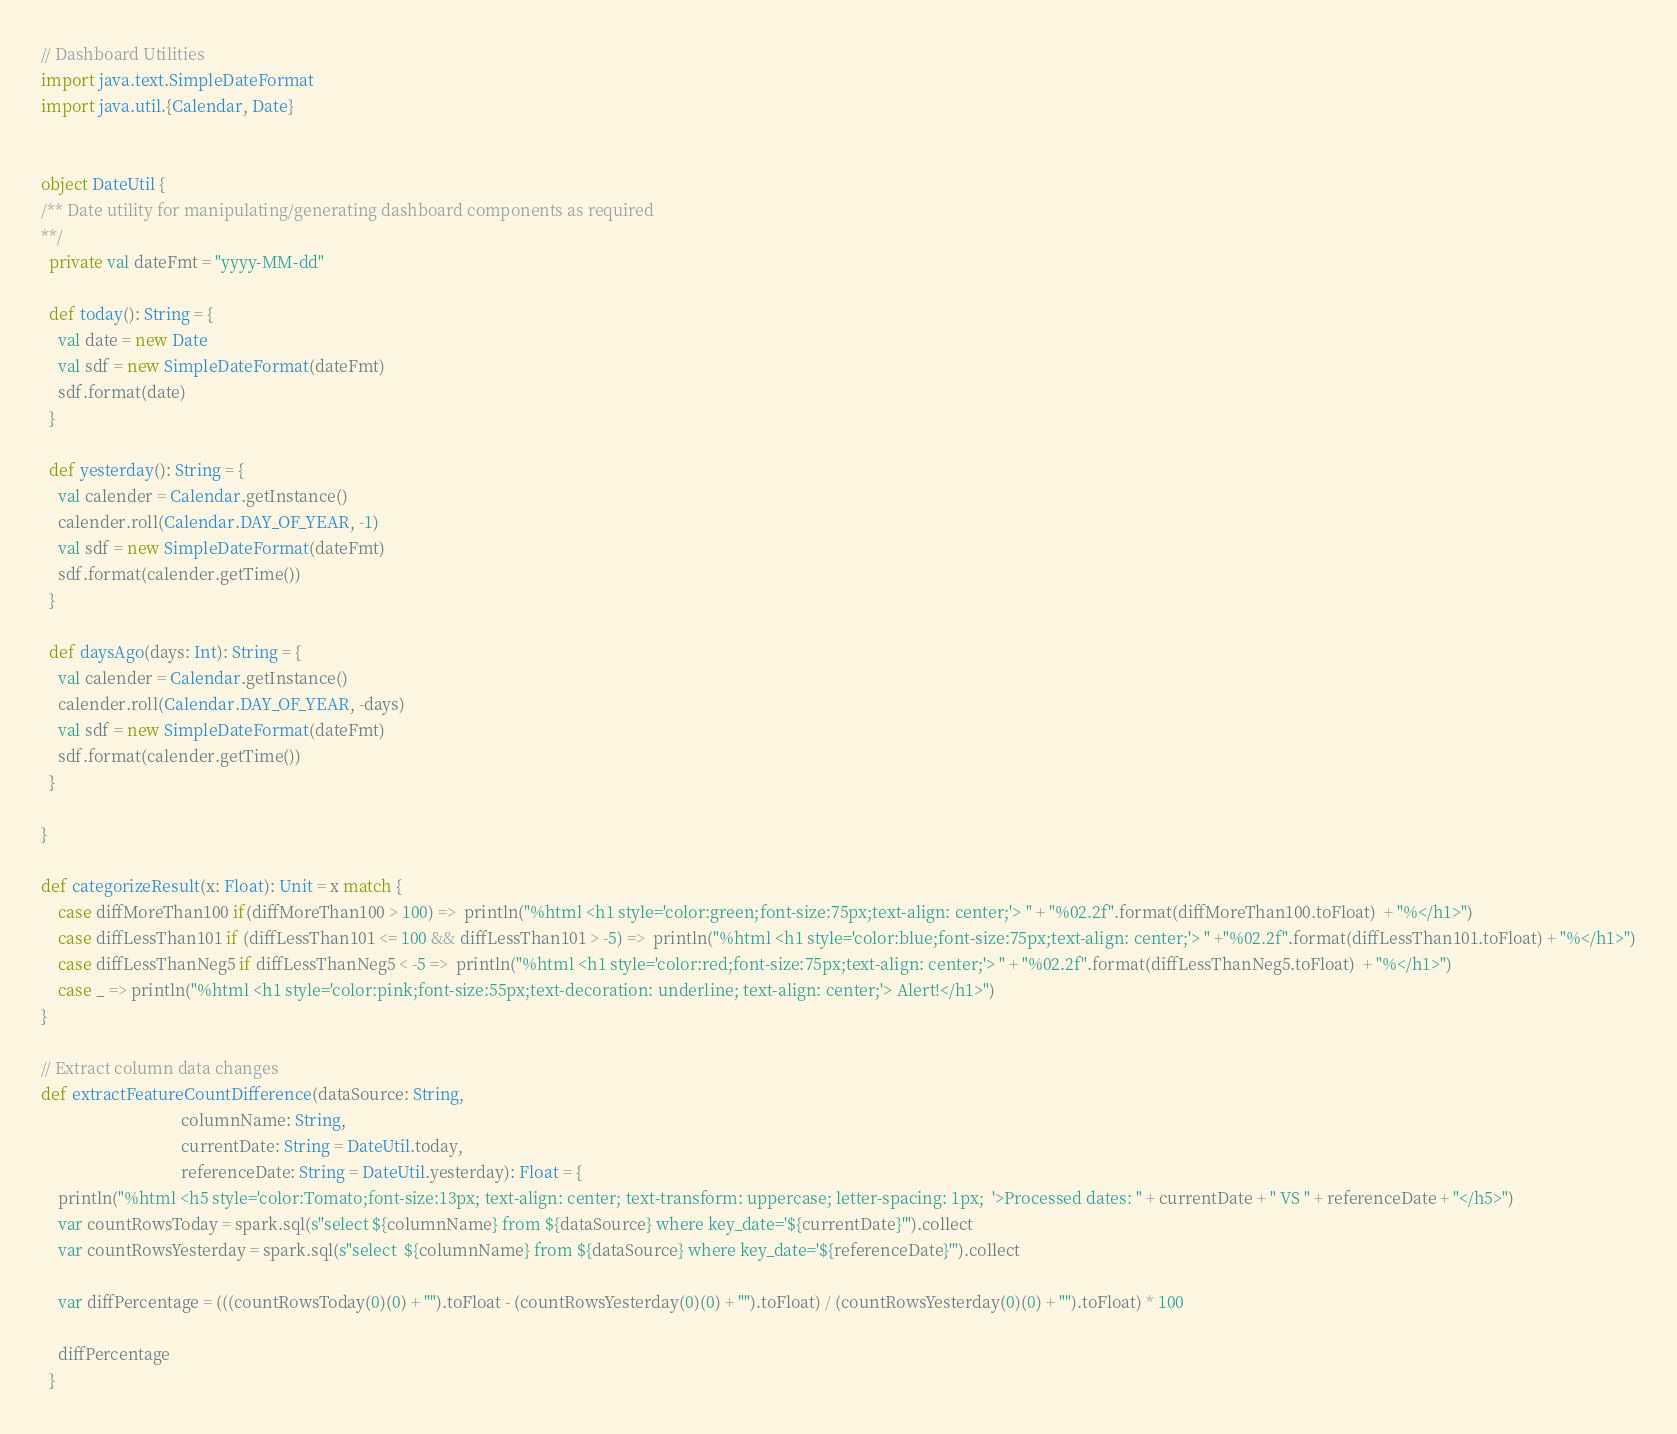Convert code to text. <code><loc_0><loc_0><loc_500><loc_500><_Scala_>// Dashboard Utilities
import java.text.SimpleDateFormat
import java.util.{Calendar, Date}


object DateUtil {
/** Date utility for manipulating/generating dashboard components as required
**/
  private val dateFmt = "yyyy-MM-dd"

  def today(): String = {
    val date = new Date
    val sdf = new SimpleDateFormat(dateFmt)
    sdf.format(date)
  }

  def yesterday(): String = {
    val calender = Calendar.getInstance()
    calender.roll(Calendar.DAY_OF_YEAR, -1)
    val sdf = new SimpleDateFormat(dateFmt)
    sdf.format(calender.getTime())
  }

  def daysAgo(days: Int): String = {
    val calender = Calendar.getInstance()
    calender.roll(Calendar.DAY_OF_YEAR, -days)
    val sdf = new SimpleDateFormat(dateFmt)
    sdf.format(calender.getTime())
  }

} 

def categorizeResult(x: Float): Unit = x match {
    case diffMoreThan100 if(diffMoreThan100 > 100) =>  println("%html <h1 style='color:green;font-size:75px;text-align: center;'> " + "%02.2f".format(diffMoreThan100.toFloat)  + "%</h1>")
    case diffLessThan101 if (diffLessThan101 <= 100 && diffLessThan101 > -5) =>  println("%html <h1 style='color:blue;font-size:75px;text-align: center;'> " +"%02.2f".format(diffLessThan101.toFloat) + "%</h1>")
    case diffLessThanNeg5 if diffLessThanNeg5 < -5 =>  println("%html <h1 style='color:red;font-size:75px;text-align: center;'> " + "%02.2f".format(diffLessThanNeg5.toFloat)  + "%</h1>")
    case _ => println("%html <h1 style='color:pink;font-size:55px;text-decoration: underline; text-align: center;'> Alert!</h1>")
}

// Extract column data changes
def extractFeatureCountDifference(dataSource: String,
                                  columnName: String,
                                  currentDate: String = DateUtil.today,
                                  referenceDate: String = DateUtil.yesterday): Float = {
    println("%html <h5 style='color:Tomato;font-size:13px; text-align: center; text-transform: uppercase; letter-spacing: 1px;  '>Processed dates: " + currentDate + " VS " + referenceDate + "</h5>")  
    var countRowsToday = spark.sql(s"select ${columnName} from ${dataSource} where key_date='${currentDate}'").collect
    var countRowsYesterday = spark.sql(s"select  ${columnName} from ${dataSource} where key_date='${referenceDate}'").collect

    var diffPercentage = (((countRowsToday(0)(0) + "").toFloat - (countRowsYesterday(0)(0) + "").toFloat) / (countRowsYesterday(0)(0) + "").toFloat) * 100
    
    diffPercentage
  }
</code> 